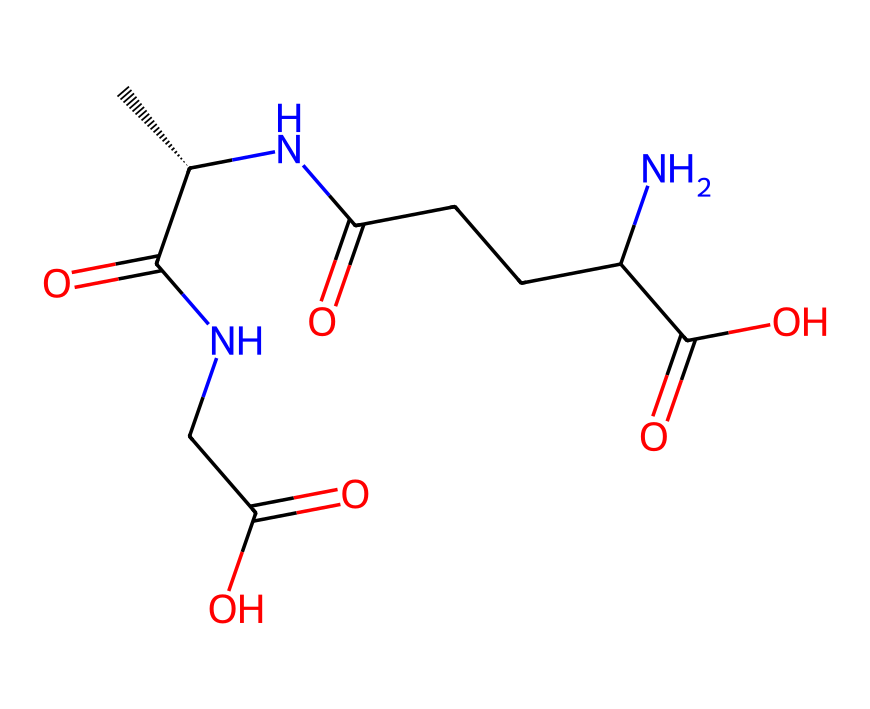What is the molecular formula of L-theanine? The molecular formula can be derived from the SMILES representation by counting the number of each type of atom present. The SMILES indicates there are 8 Carbon (C) atoms, 14 Hydrogen (H) atoms, 2 Nitrogen (N) atoms, and 4 Oxygen (O) atoms, leading to the formula C8H14N2O4.
Answer: C8H14N2O4 How many stereocenters are present in L-theanine? A stereocenter is identified in the chemical structure by analyzing the carbon atoms that are bonded to four different substituents. In this case, there is one stereocenter located at the carbon indicated by [C@H], which has different groups attached to it.
Answer: 1 What type of bonds are primarily present in L-theanine? Bonds can be identified through the SMILES representation. The structure contains single bonds (represented normally), double bonds (indicated by "="), and amide bonds (indicated by "NC(=O)"). The predominant bond type is single, as most carbon atoms are connected by single bonds.
Answer: single bonds What functional groups are present in L-theanine? The functional groups can be identified in the SMILES by analyzing the provided structure. The molecule contains amine (NH2), carboxylic acid (-COOH), and amide (C(=O)N). Since there are multiple functional groups, they contribute to both properties and reactivity.
Answer: amine, carboxylic acid, amide How does L-theanine relate to stress reduction? The relationship is understood through the molecular structure's influence on neurotransmitter modulation. L-theanine can affect glutamate and serotonin levels due to its structural similarity to these neurotransmitters, helping to promote relaxation without drowsiness.
Answer: neurotransmitter modulation What are the potential effects of L-theanine on cognitive functions? This relationship is based on the chemical's ability to cross the blood-brain barrier and its influence on alpha brain wave activity, which is linked to relaxation and improved concentration. This indicates that the compound can enhance cognitive performance through its specific chemical interactions.
Answer: improved concentration Which atoms contribute to the overall polarity of L-theanine? Polarity is determined by the presence of electronegative atoms and functional groups. In L-theanine, the oxygen and nitrogen atoms, especially in the carboxylic acid and amide groups, contribute to its overall polarity due to their electronegativity.
Answer: oxygen and nitrogen 